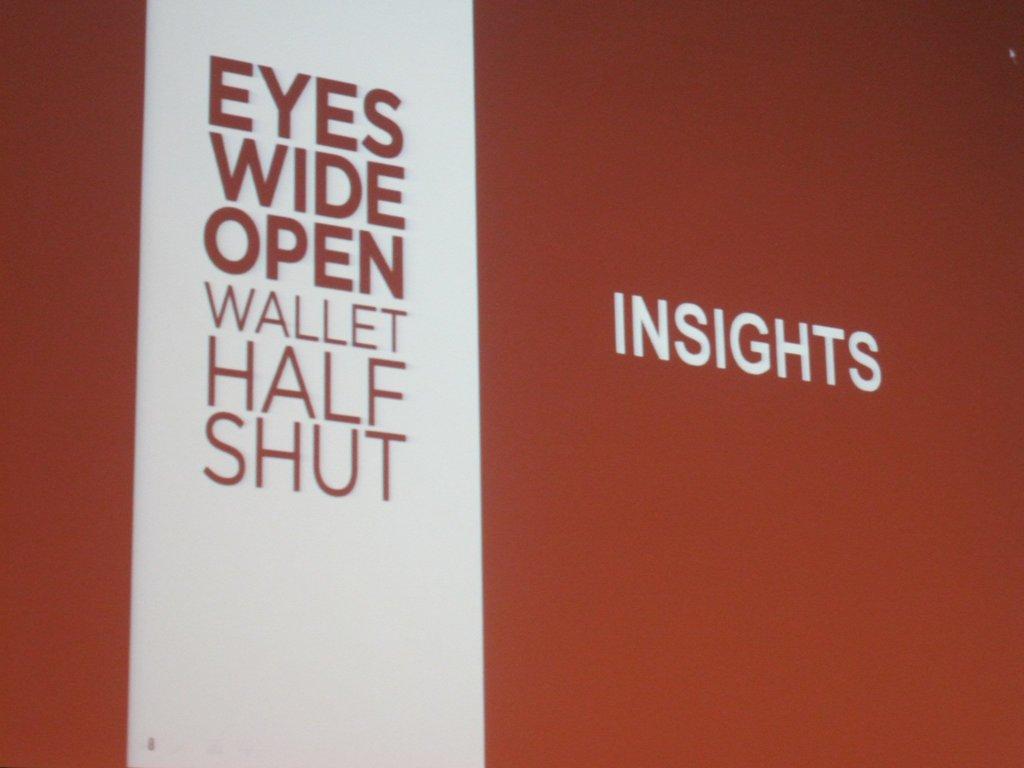What company does this sign represent?
Your response must be concise. Insights. What word is all by itself on the right?
Ensure brevity in your answer.  Insights. 